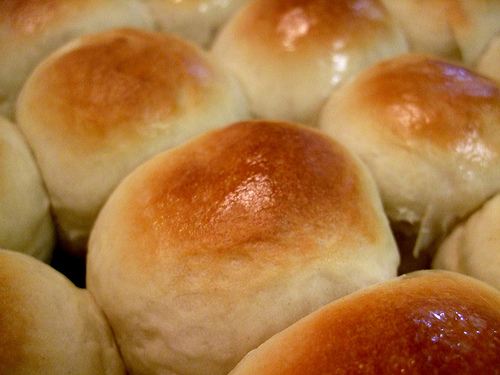<image>
Is there a toaster on the donut? No. The toaster is not positioned on the donut. They may be near each other, but the toaster is not supported by or resting on top of the donut. 